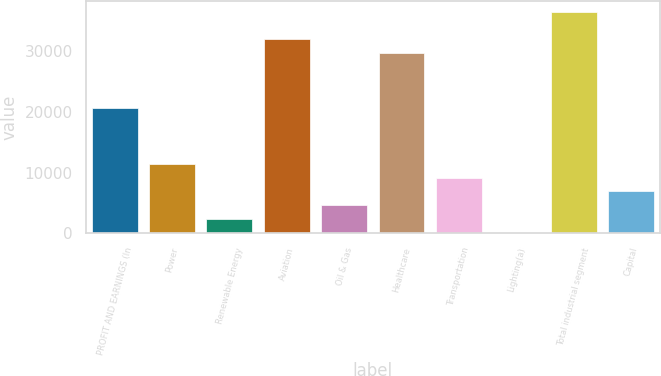<chart> <loc_0><loc_0><loc_500><loc_500><bar_chart><fcel>PROFIT AND EARNINGS (In<fcel>Power<fcel>Renewable Energy<fcel>Aviation<fcel>Oil & Gas<fcel>Healthcare<fcel>Transportation<fcel>Lighting(a)<fcel>Total industrial segment<fcel>Capital<nl><fcel>20528.8<fcel>11436<fcel>2343.2<fcel>31894.8<fcel>4616.4<fcel>29621.6<fcel>9162.8<fcel>70<fcel>36441.2<fcel>6889.6<nl></chart> 